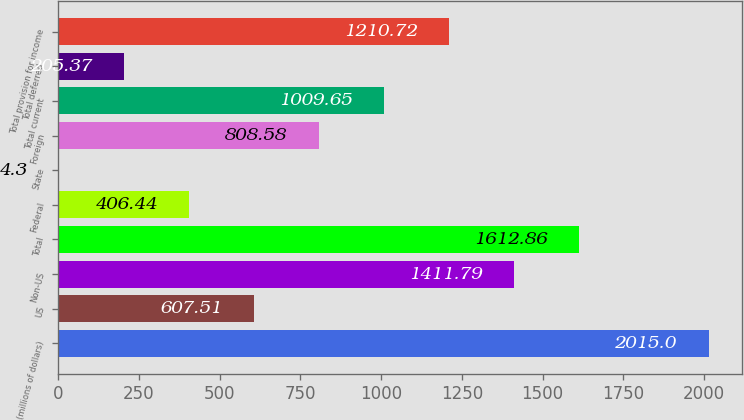Convert chart. <chart><loc_0><loc_0><loc_500><loc_500><bar_chart><fcel>(millions of dollars)<fcel>US<fcel>Non-US<fcel>Total<fcel>Federal<fcel>State<fcel>Foreign<fcel>Total current<fcel>Total deferred<fcel>Total provision for income<nl><fcel>2015<fcel>607.51<fcel>1411.79<fcel>1612.86<fcel>406.44<fcel>4.3<fcel>808.58<fcel>1009.65<fcel>205.37<fcel>1210.72<nl></chart> 